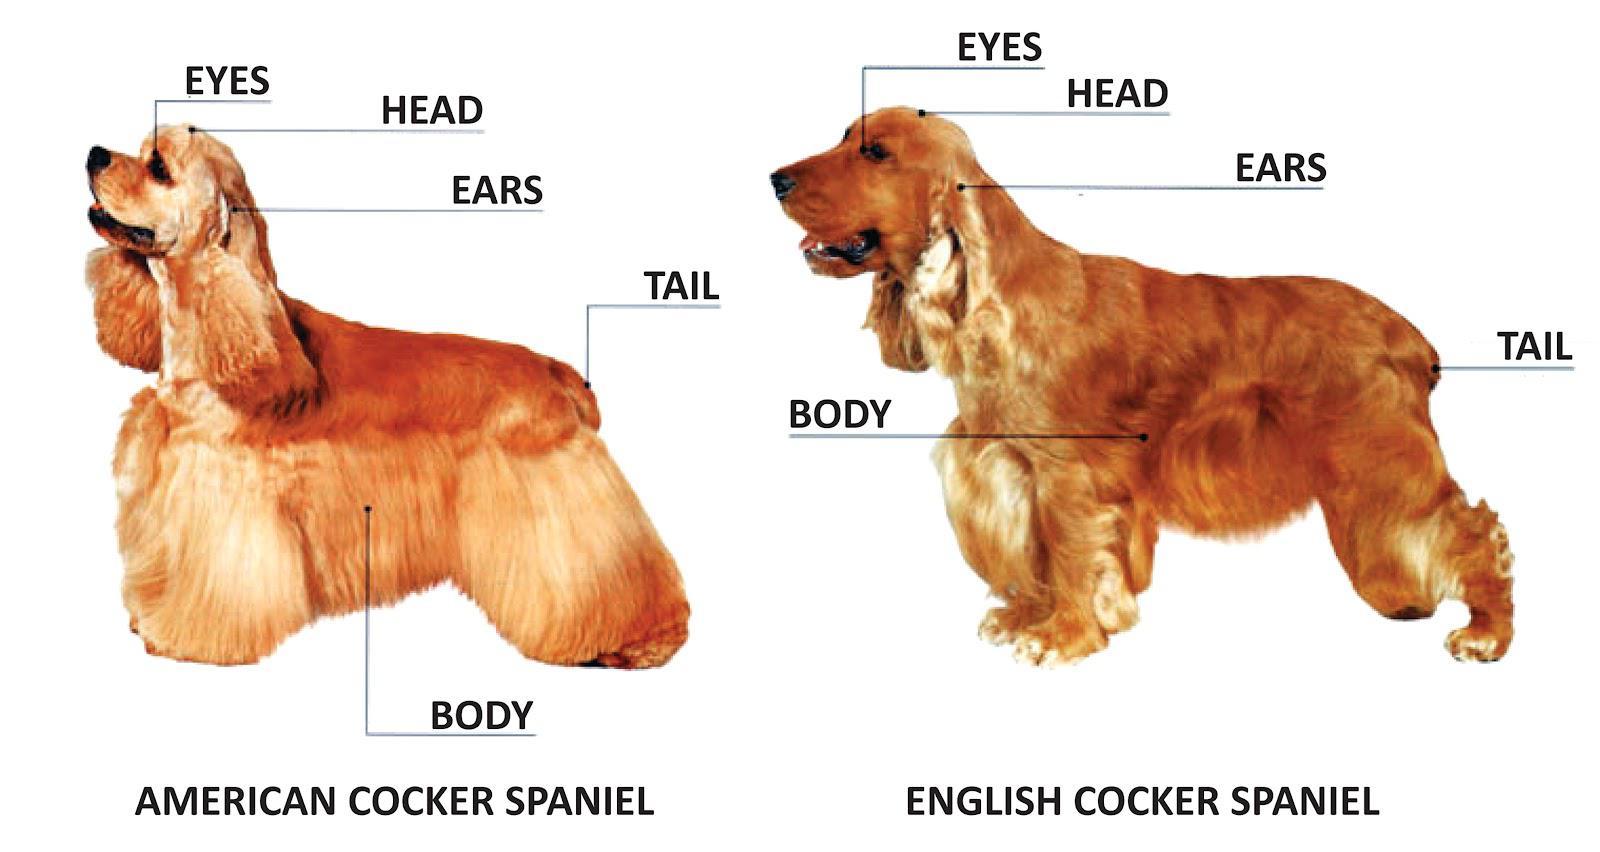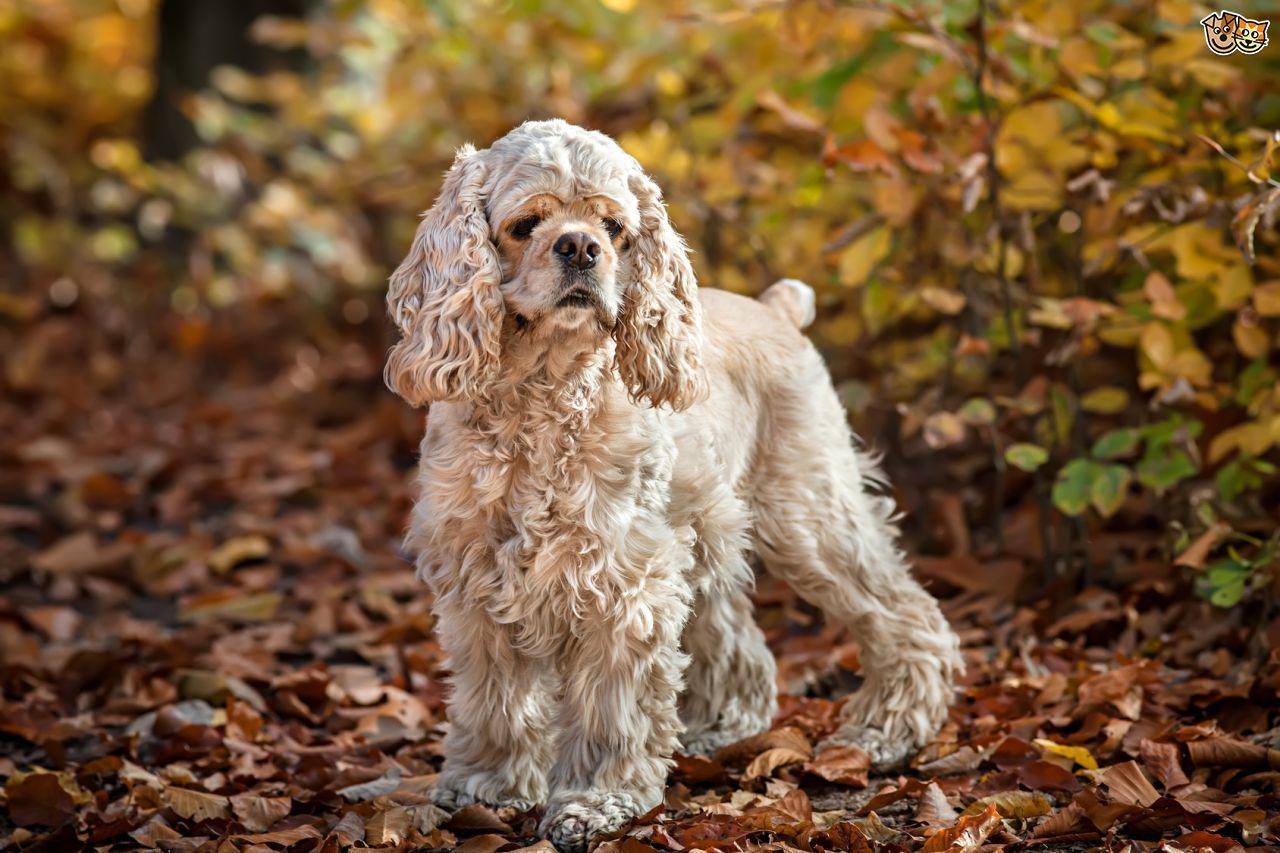The first image is the image on the left, the second image is the image on the right. Given the left and right images, does the statement "There is at least one dog with some black fur." hold true? Answer yes or no. No. The first image is the image on the left, the second image is the image on the right. Assess this claim about the two images: "There are two dogs facing forward with their tongues out in the image on the right.". Correct or not? Answer yes or no. No. 